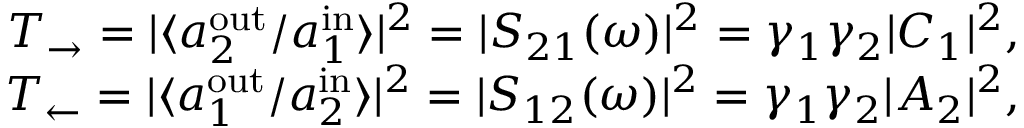<formula> <loc_0><loc_0><loc_500><loc_500>\begin{array} { r } { T _ { \rightarrow } = | \langle a _ { 2 } ^ { o u t } / a _ { 1 } ^ { i n } \rangle | ^ { 2 } = | S _ { 2 1 } ( \omega ) | ^ { 2 } = \gamma _ { 1 } \gamma _ { 2 } | C _ { 1 } | ^ { 2 } , } \\ { T _ { \leftarrow } = | \langle a _ { 1 } ^ { o u t } / a _ { 2 } ^ { i n } \rangle | ^ { 2 } = | S _ { 1 2 } ( \omega ) | ^ { 2 } = \gamma _ { 1 } \gamma _ { 2 } | A _ { 2 } | ^ { 2 } , } \end{array}</formula> 